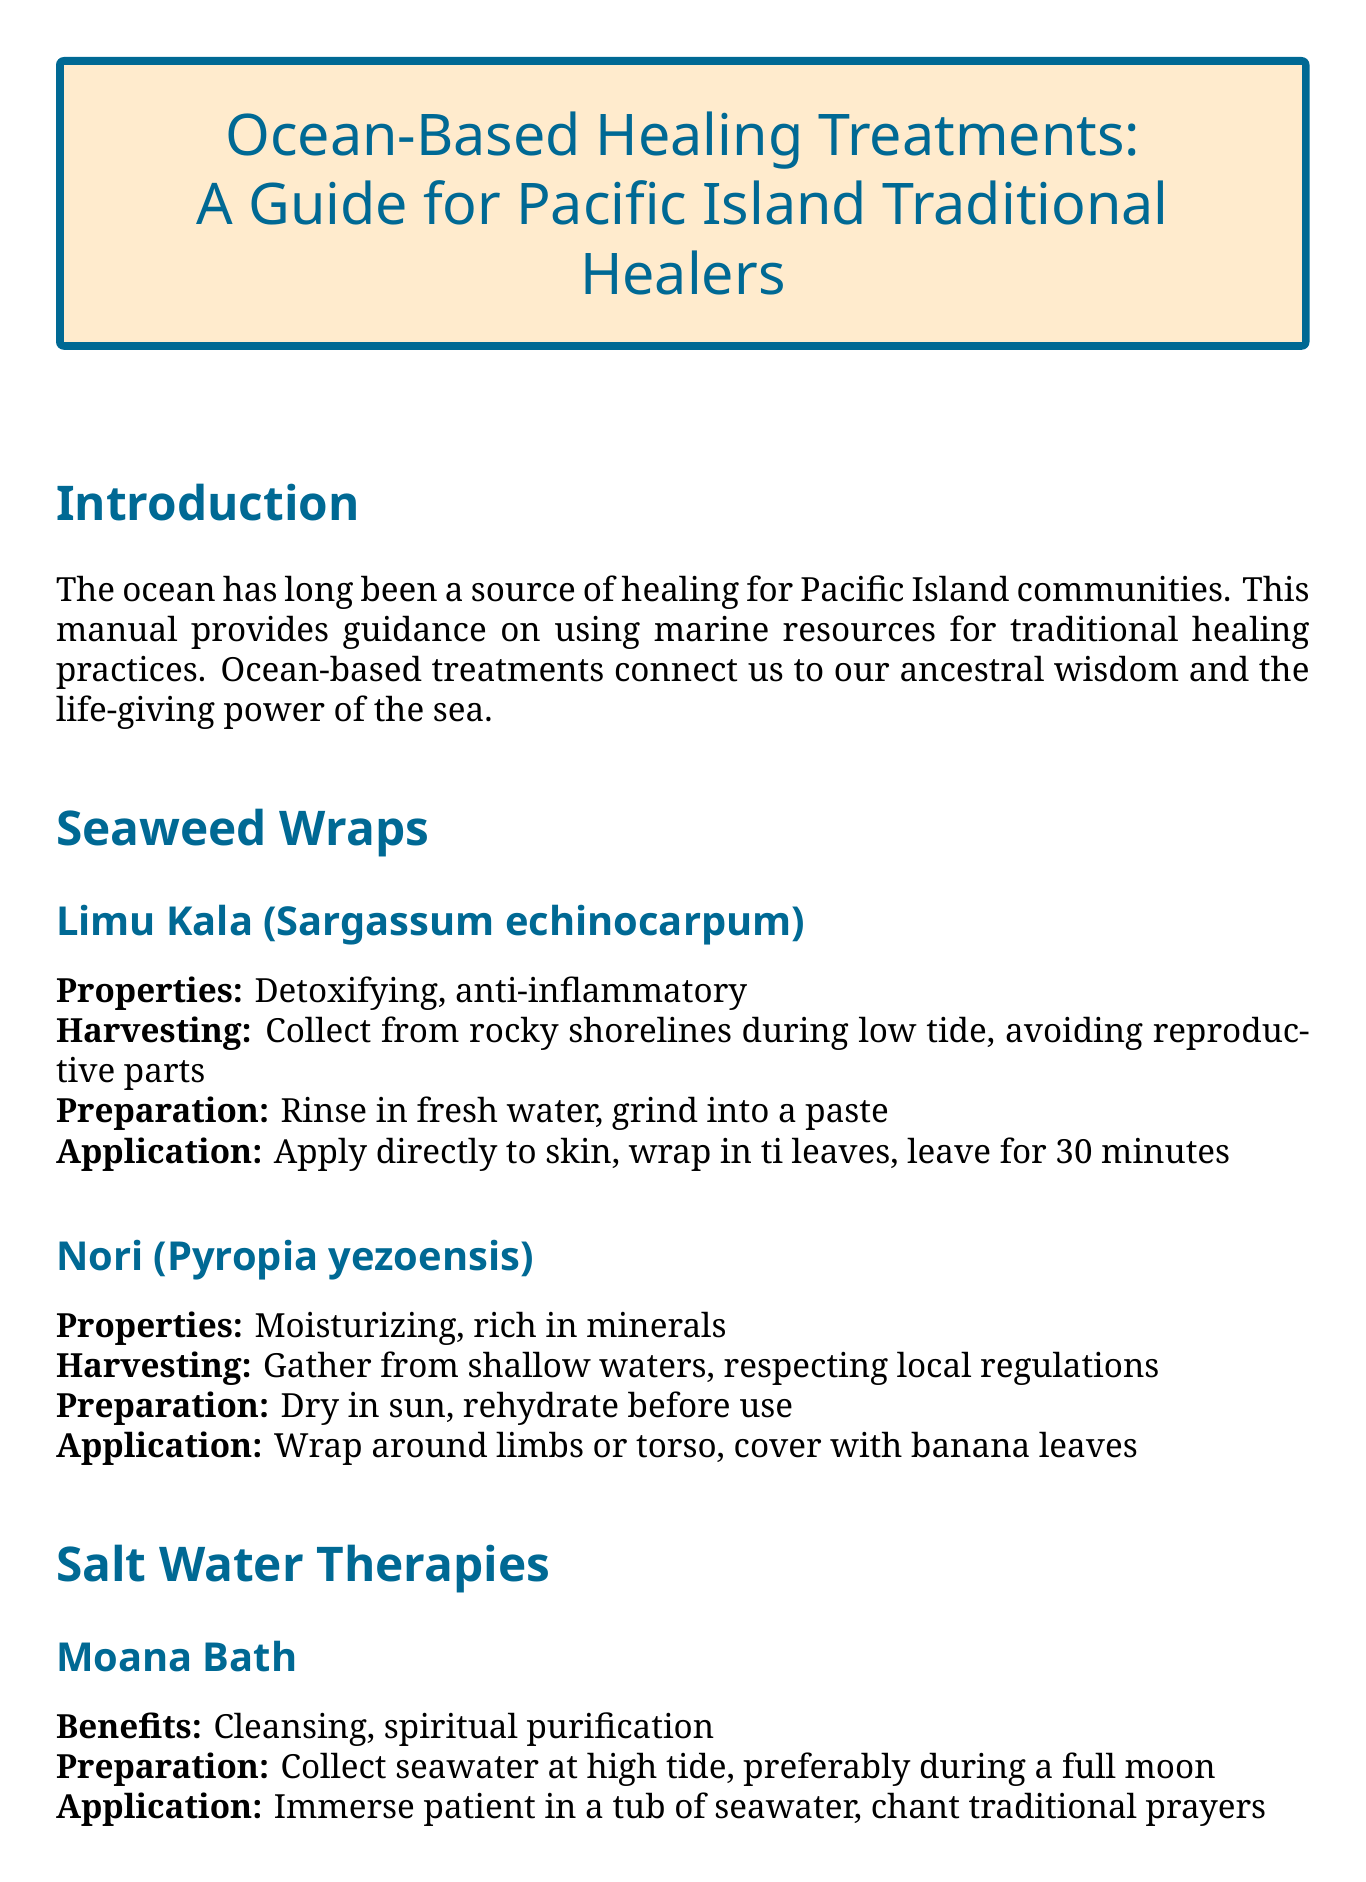What are the properties of Limu Kala? The properties are listed in the document under the section for Limu Kala (Sargassum echinocarpum).
Answer: Detoxifying, anti-inflammatory How is the Moana Bath prepared? The preparation method for the Moana Bath is explained in the Salt Water Therapies section.
Answer: Collect seawater at high tide, preferably during a full moon What should you avoid during harvesting? The document lists guidelines for harvesting, including precautions to take.
Answer: Avoid harvesting during spawning seasons What is one benefit of the Coral Sand Scrub? Benefits are listed for each therapy, specifically in the Coral Sand Scrub section.
Answer: Exfoliation, improved circulation What traditional tool is suggested for harvesting? The document mentions specific tools that should be used for harvesting marine resources.
Answer: Coconut fiber nets or bamboo baskets How long should a seaweed wrap be left on the skin? The application instructions for seaweed wraps specify the duration for leaving the treatment on.
Answer: Leave for 30 minutes What should be done before applying treatments? The preparation section outlines the cleanse before applying treatments.
Answer: Cleanse treatment area with ti leaf infused water What should you offer to the ocean in gratitude? The guidelines for harvesting include a practice of giving thanks to the ocean.
Answer: A small gift (e.g., flowers) 